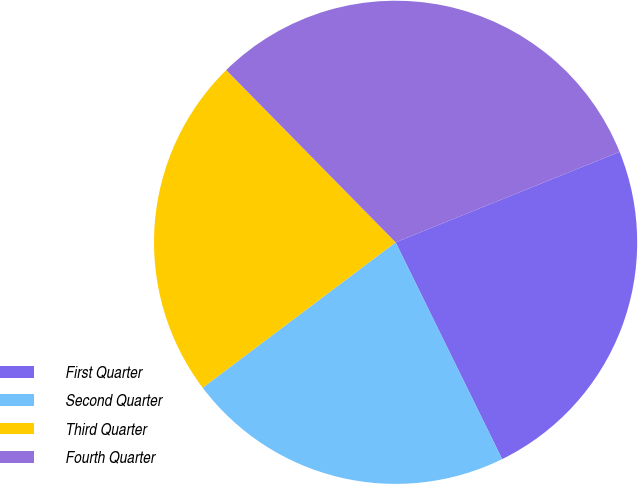Convert chart. <chart><loc_0><loc_0><loc_500><loc_500><pie_chart><fcel>First Quarter<fcel>Second Quarter<fcel>Third Quarter<fcel>Fourth Quarter<nl><fcel>23.84%<fcel>21.99%<fcel>22.91%<fcel>31.26%<nl></chart> 